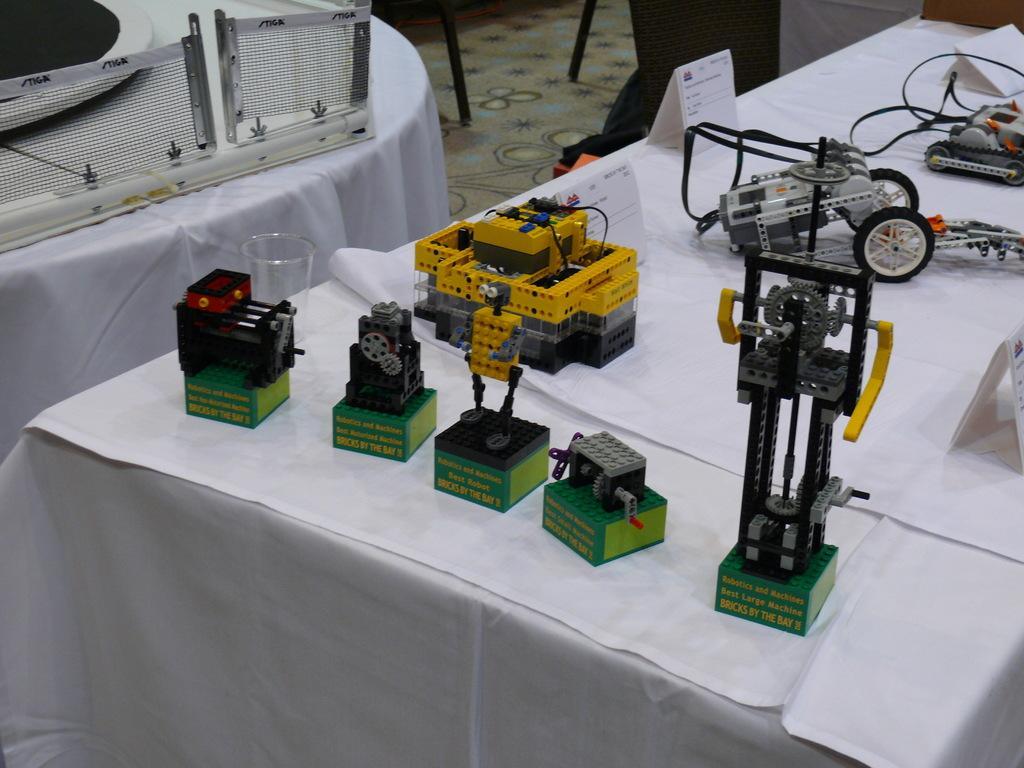Describe this image in one or two sentences. In the foreground there is a table covered with cloth. On the table there are small machines and name plates. On the left there is a table, on the table there are net and other objects. At the top there are persons legs. 